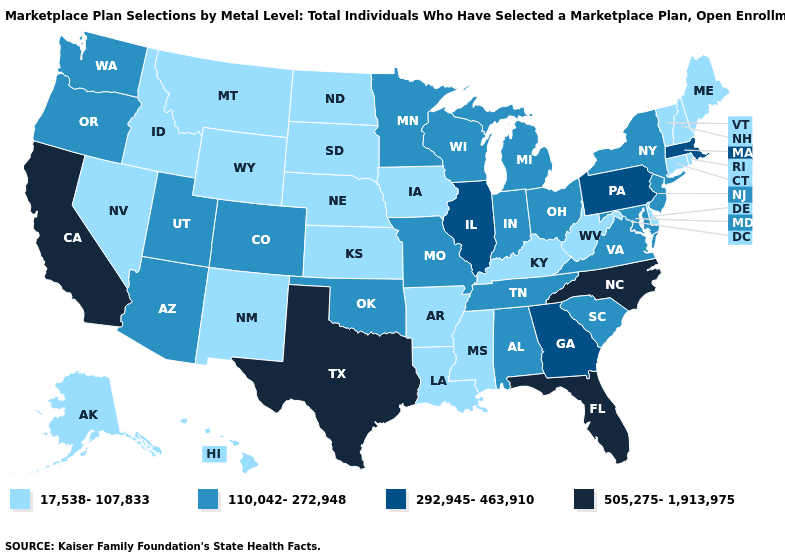Does Michigan have a lower value than Pennsylvania?
Quick response, please. Yes. What is the value of Delaware?
Short answer required. 17,538-107,833. Does Arizona have the highest value in the USA?
Be succinct. No. Does the map have missing data?
Short answer required. No. Name the states that have a value in the range 110,042-272,948?
Keep it brief. Alabama, Arizona, Colorado, Indiana, Maryland, Michigan, Minnesota, Missouri, New Jersey, New York, Ohio, Oklahoma, Oregon, South Carolina, Tennessee, Utah, Virginia, Washington, Wisconsin. Which states have the highest value in the USA?
Be succinct. California, Florida, North Carolina, Texas. What is the value of Wyoming?
Give a very brief answer. 17,538-107,833. What is the lowest value in the West?
Short answer required. 17,538-107,833. Name the states that have a value in the range 110,042-272,948?
Keep it brief. Alabama, Arizona, Colorado, Indiana, Maryland, Michigan, Minnesota, Missouri, New Jersey, New York, Ohio, Oklahoma, Oregon, South Carolina, Tennessee, Utah, Virginia, Washington, Wisconsin. Does the map have missing data?
Concise answer only. No. Name the states that have a value in the range 110,042-272,948?
Answer briefly. Alabama, Arizona, Colorado, Indiana, Maryland, Michigan, Minnesota, Missouri, New Jersey, New York, Ohio, Oklahoma, Oregon, South Carolina, Tennessee, Utah, Virginia, Washington, Wisconsin. What is the lowest value in the USA?
Answer briefly. 17,538-107,833. Is the legend a continuous bar?
Short answer required. No. Does Arizona have the same value as Utah?
Short answer required. Yes. What is the value of North Dakota?
Quick response, please. 17,538-107,833. 